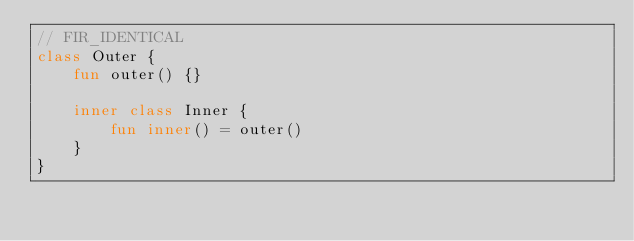Convert code to text. <code><loc_0><loc_0><loc_500><loc_500><_Kotlin_>// FIR_IDENTICAL
class Outer {
    fun outer() {}

    inner class Inner {
        fun inner() = outer()
    }
}</code> 